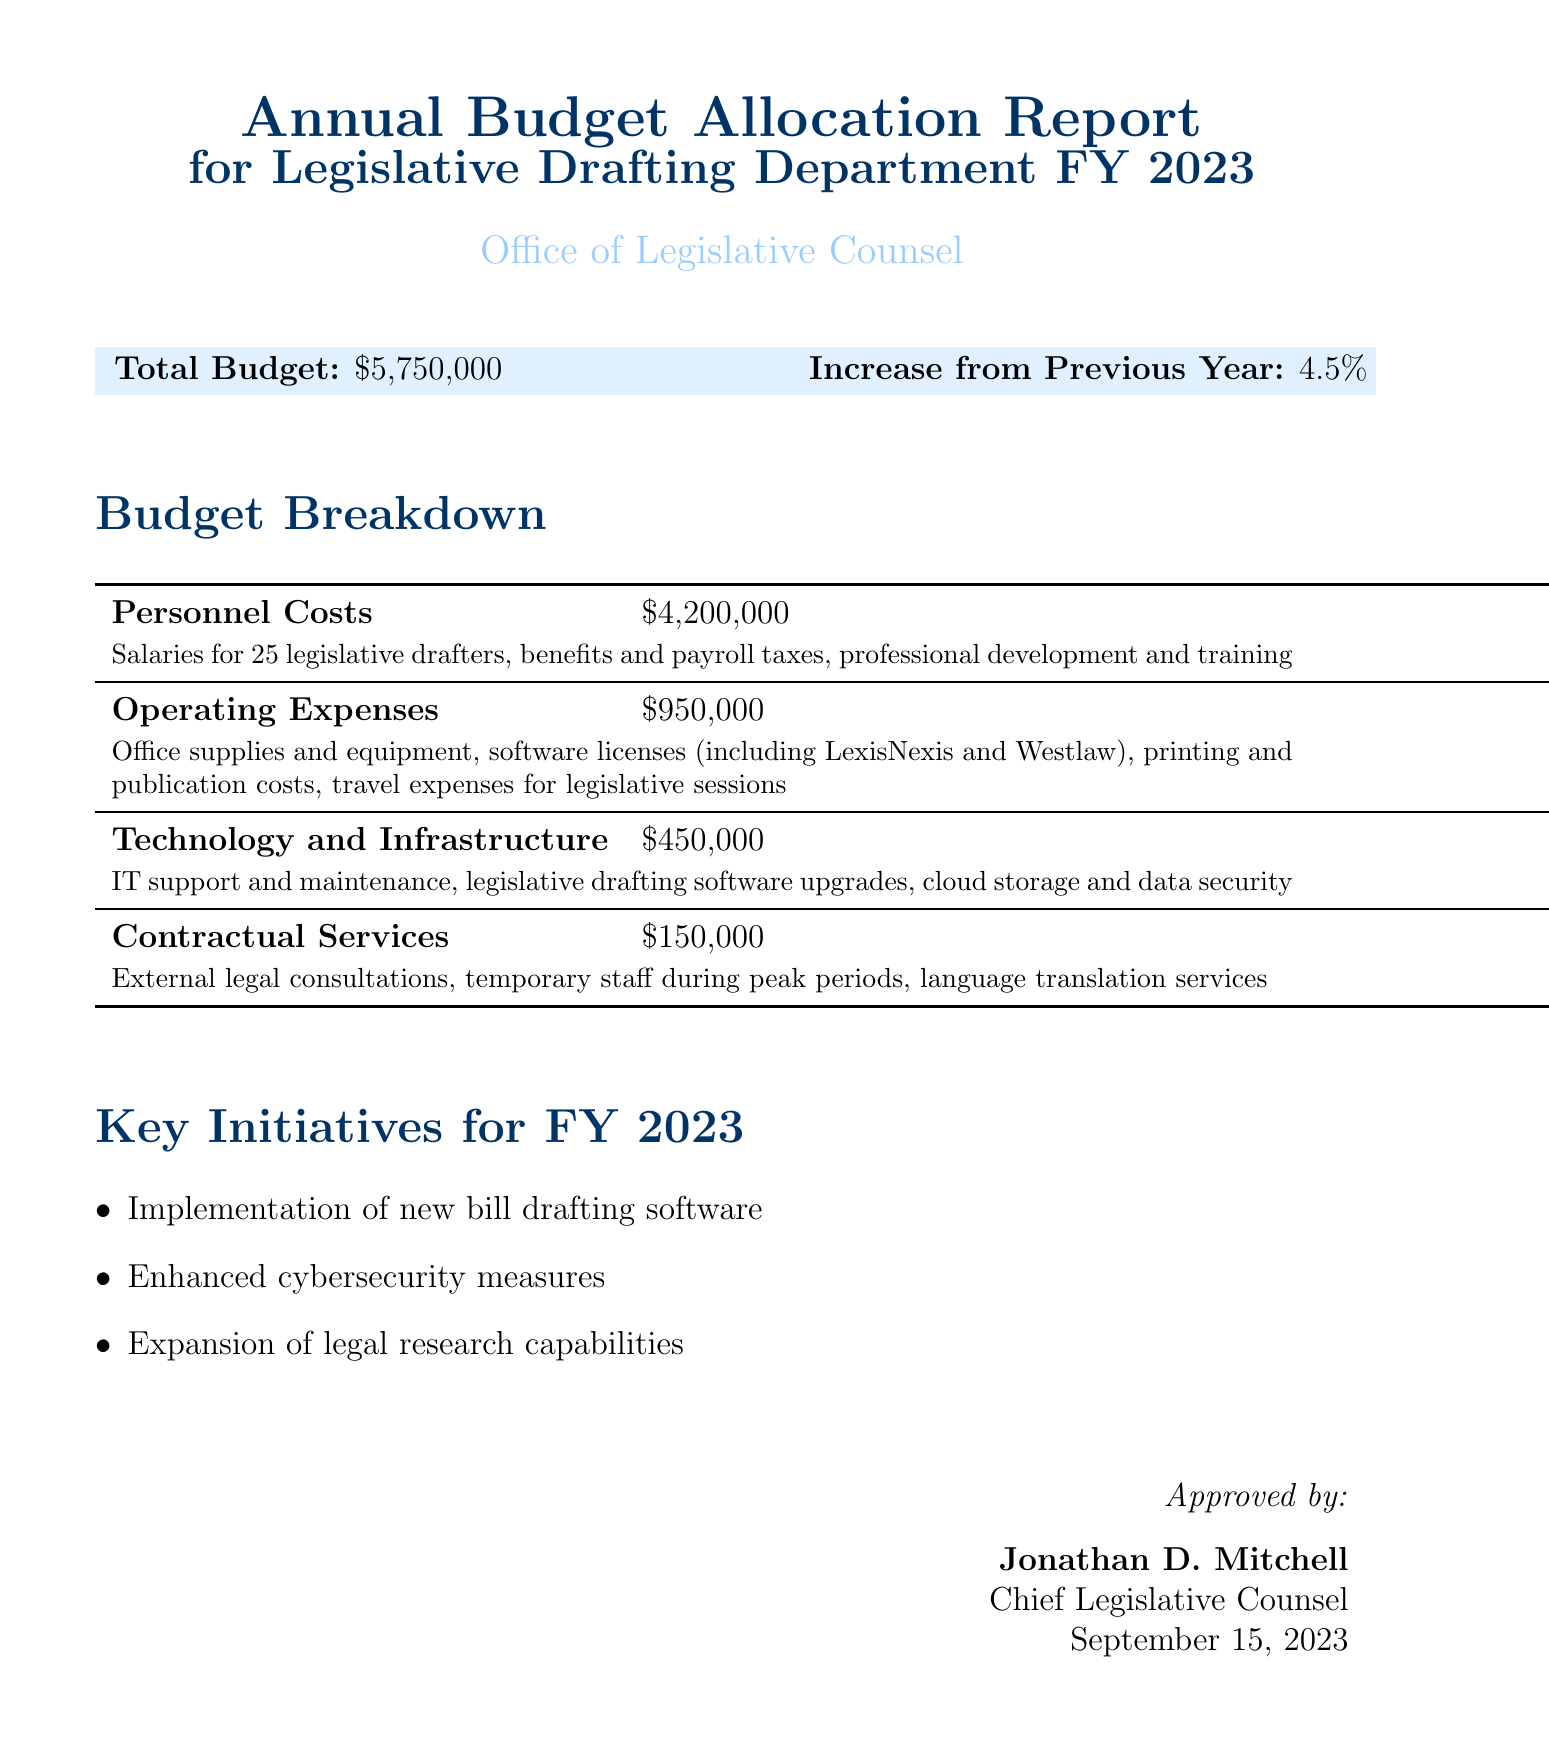What is the total budget for FY 2023? The total budget for FY 2023 is specified at the beginning of the report.
Answer: $5,750,000 Who is the Chief Legislative Counsel? The document includes an approval signature section, where the name of the Chief Legislative Counsel is provided.
Answer: Jonathan D. Mitchell What is the amount allocated for Operating Expenses? The budget breakdown section lists the amount allocated specifically for Operating Expenses.
Answer: $950,000 What are the key initiatives for FY 2023? The report outlines the key initiatives in a separate section, listing them directly.
Answer: Implementation of new bill drafting software, Enhanced cybersecurity measures, Expansion of legal research capabilities By how much has the budget increased from the previous year? The document provides a direct comparison with the previous year's budget increase percentage.
Answer: 4.5% What is the total amount allocated for Personnel Costs? The budget breakdown specifies the amount dedicated to Personnel Costs distinctly.
Answer: $4,200,000 